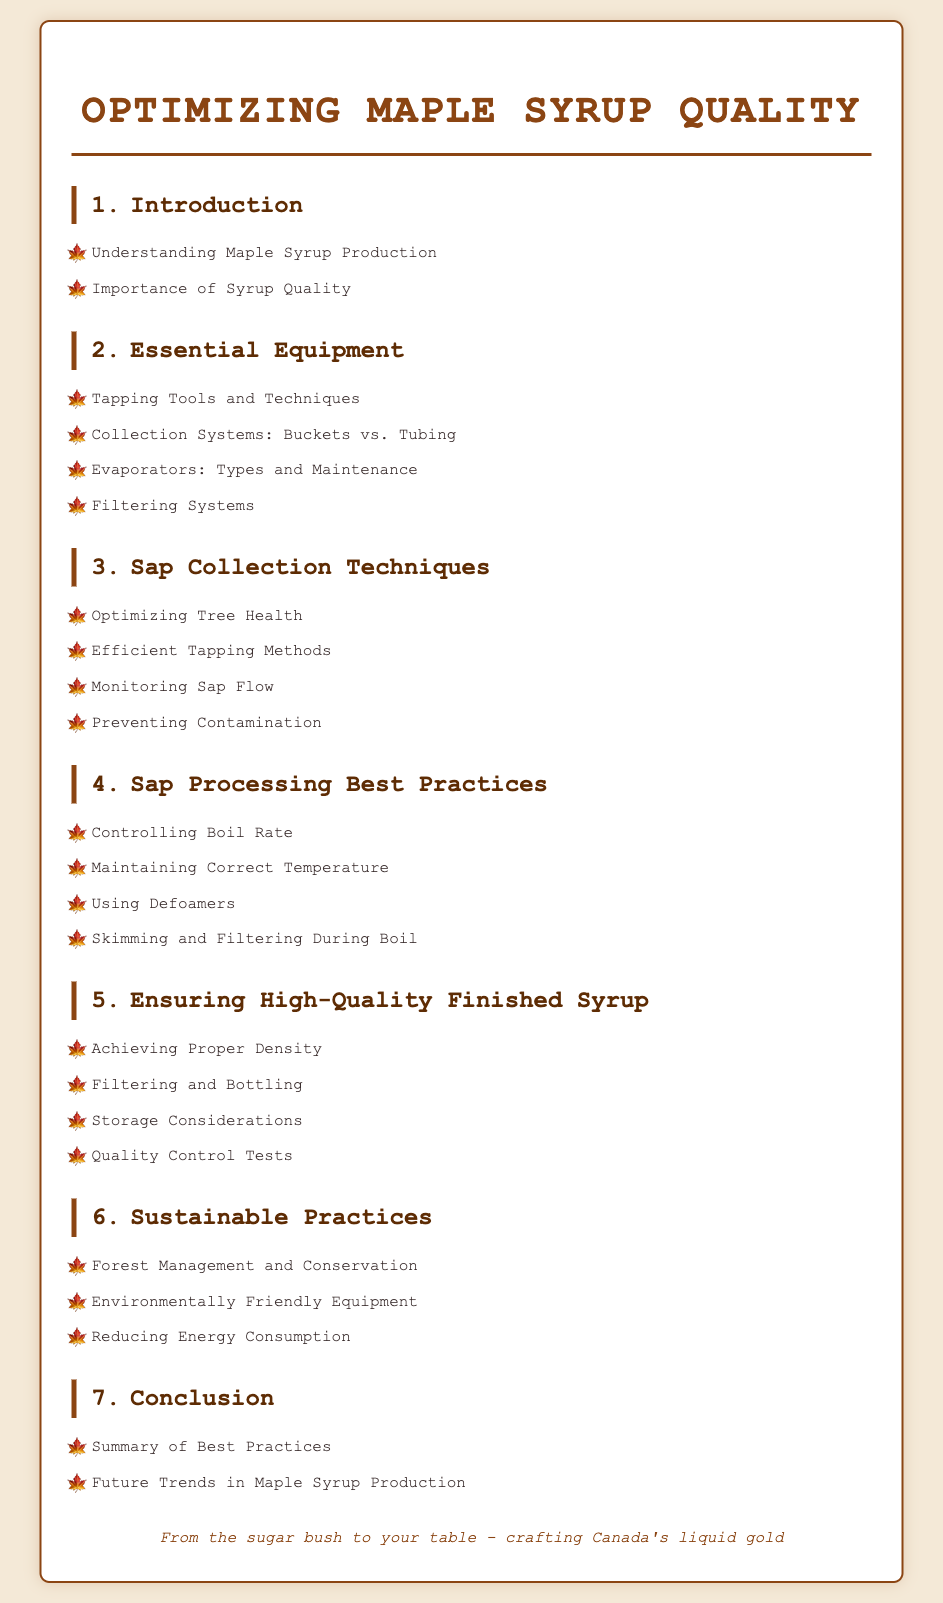What is the first chapter? The first chapter listed in the table of contents is "Introduction."
Answer: Introduction How many chapters are there in total? The total number of chapters presented in the table of contents is seven.
Answer: 7 What is one method of sap collection mentioned? One method of sap collection mentioned is "Efficient Tapping Methods."
Answer: Efficient Tapping Methods What type of equipment is discussed in chapter 2? Chapter 2 discusses "Essential Equipment," which includes tapping tools and evaporators.
Answer: Essential Equipment What is a sustainable practice indicated in the document? "Forest Management and Conservation" is listed as a sustainable practice.
Answer: Forest Management and Conservation Which section addresses the quality of finished syrup? The section addressing the quality of finished syrup is "Ensuring High-Quality Finished Syrup."
Answer: Ensuring High-Quality Finished Syrup How many items are listed under Sap Processing Best Practices? There are four items listed under "Sap Processing Best Practices."
Answer: 4 What does the footer of the document convey? The footer conveys the message about crafting Canada's liquid gold from the sugar bush to the table.
Answer: crafting Canada's liquid gold What practice is emphasized for monitoring tap placements? "Preventing Contamination" is emphasized as a practice related to monitoring tap placements.
Answer: Preventing Contamination 